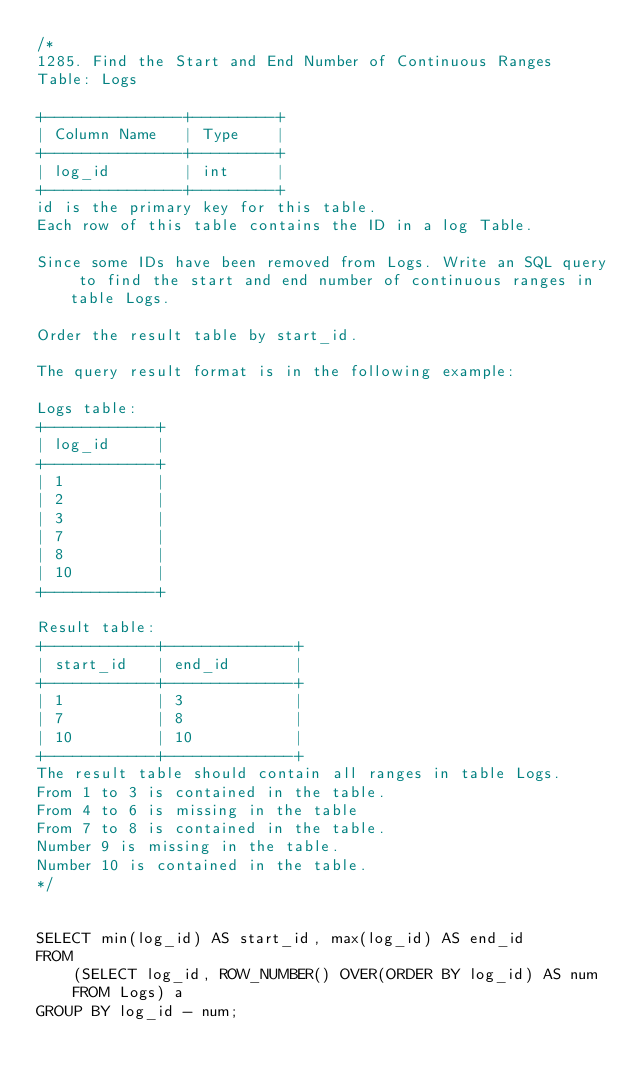Convert code to text. <code><loc_0><loc_0><loc_500><loc_500><_SQL_>/*
1285. Find the Start and End Number of Continuous Ranges
Table: Logs

+---------------+---------+
| Column Name   | Type    |
+---------------+---------+
| log_id        | int     |
+---------------+---------+
id is the primary key for this table.
Each row of this table contains the ID in a log Table.

Since some IDs have been removed from Logs. Write an SQL query to find the start and end number of continuous ranges in table Logs.

Order the result table by start_id.

The query result format is in the following example:

Logs table:
+------------+
| log_id     |
+------------+
| 1          |
| 2          |
| 3          |
| 7          |
| 8          |
| 10         |
+------------+

Result table:
+------------+--------------+
| start_id   | end_id       |
+------------+--------------+
| 1          | 3            |
| 7          | 8            |
| 10         | 10           |
+------------+--------------+
The result table should contain all ranges in table Logs.
From 1 to 3 is contained in the table.
From 4 to 6 is missing in the table
From 7 to 8 is contained in the table.
Number 9 is missing in the table.
Number 10 is contained in the table.
*/


SELECT min(log_id) AS start_id, max(log_id) AS end_id
FROM
    (SELECT log_id, ROW_NUMBER() OVER(ORDER BY log_id) AS num
    FROM Logs) a
GROUP BY log_id - num;</code> 